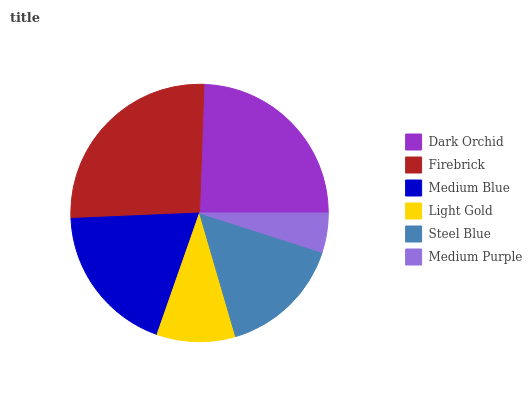Is Medium Purple the minimum?
Answer yes or no. Yes. Is Firebrick the maximum?
Answer yes or no. Yes. Is Medium Blue the minimum?
Answer yes or no. No. Is Medium Blue the maximum?
Answer yes or no. No. Is Firebrick greater than Medium Blue?
Answer yes or no. Yes. Is Medium Blue less than Firebrick?
Answer yes or no. Yes. Is Medium Blue greater than Firebrick?
Answer yes or no. No. Is Firebrick less than Medium Blue?
Answer yes or no. No. Is Medium Blue the high median?
Answer yes or no. Yes. Is Steel Blue the low median?
Answer yes or no. Yes. Is Light Gold the high median?
Answer yes or no. No. Is Light Gold the low median?
Answer yes or no. No. 